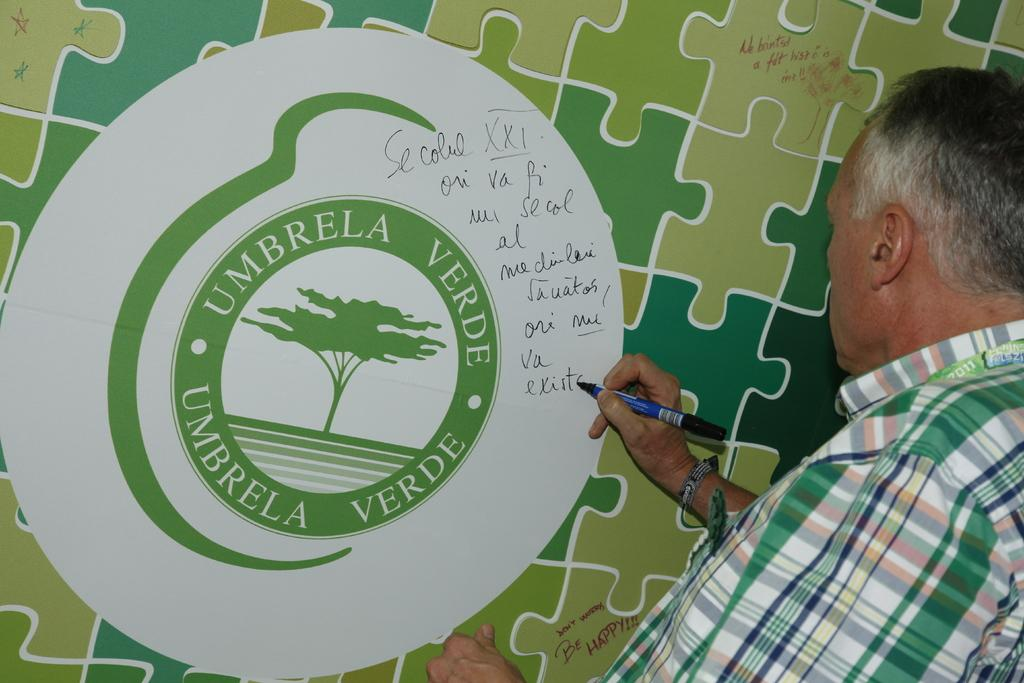What object is present in the image that has text on it? There is a board in the image that has text on it. What is the man in the image doing? The man is holding a marker and writing on the board. What might the man be using to write on the board? The man is using a marker to write on the board. Can you see any horses in the image? There are no horses present in the image. What type of creature is the man interacting with in the image? There is no creature present in the image; the man is interacting with the board and marker. 